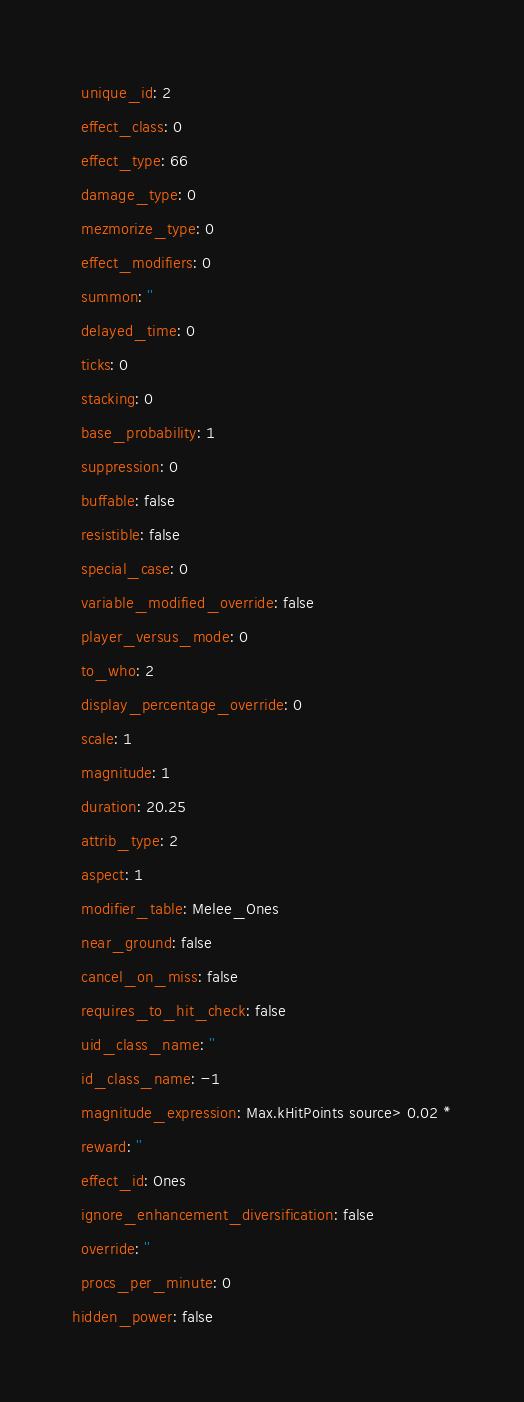<code> <loc_0><loc_0><loc_500><loc_500><_YAML_>  unique_id: 2
  effect_class: 0
  effect_type: 66
  damage_type: 0
  mezmorize_type: 0
  effect_modifiers: 0
  summon: ''
  delayed_time: 0
  ticks: 0
  stacking: 0
  base_probability: 1
  suppression: 0
  buffable: false
  resistible: false
  special_case: 0
  variable_modified_override: false
  player_versus_mode: 0
  to_who: 2
  display_percentage_override: 0
  scale: 1
  magnitude: 1
  duration: 20.25
  attrib_type: 2
  aspect: 1
  modifier_table: Melee_Ones
  near_ground: false
  cancel_on_miss: false
  requires_to_hit_check: false
  uid_class_name: ''
  id_class_name: -1
  magnitude_expression: Max.kHitPoints source> 0.02 *
  reward: ''
  effect_id: Ones
  ignore_enhancement_diversification: false
  override: ''
  procs_per_minute: 0
hidden_power: false
</code> 